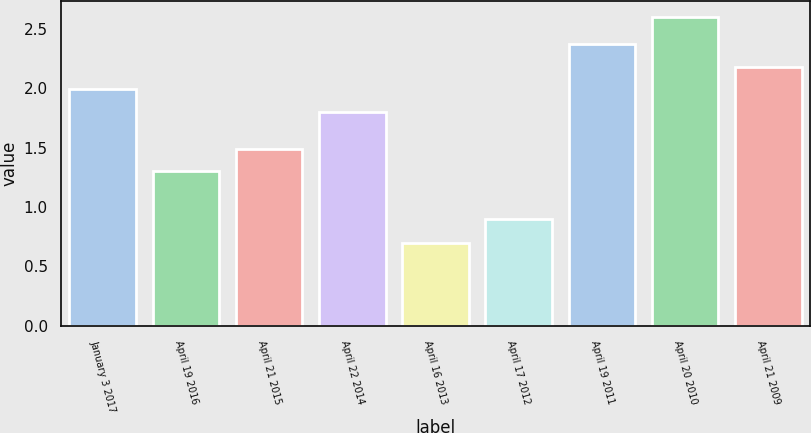Convert chart to OTSL. <chart><loc_0><loc_0><loc_500><loc_500><bar_chart><fcel>January 3 2017<fcel>April 19 2016<fcel>April 21 2015<fcel>April 22 2014<fcel>April 16 2013<fcel>April 17 2012<fcel>April 19 2011<fcel>April 20 2010<fcel>April 21 2009<nl><fcel>1.99<fcel>1.3<fcel>1.49<fcel>1.8<fcel>0.7<fcel>0.9<fcel>2.37<fcel>2.6<fcel>2.18<nl></chart> 